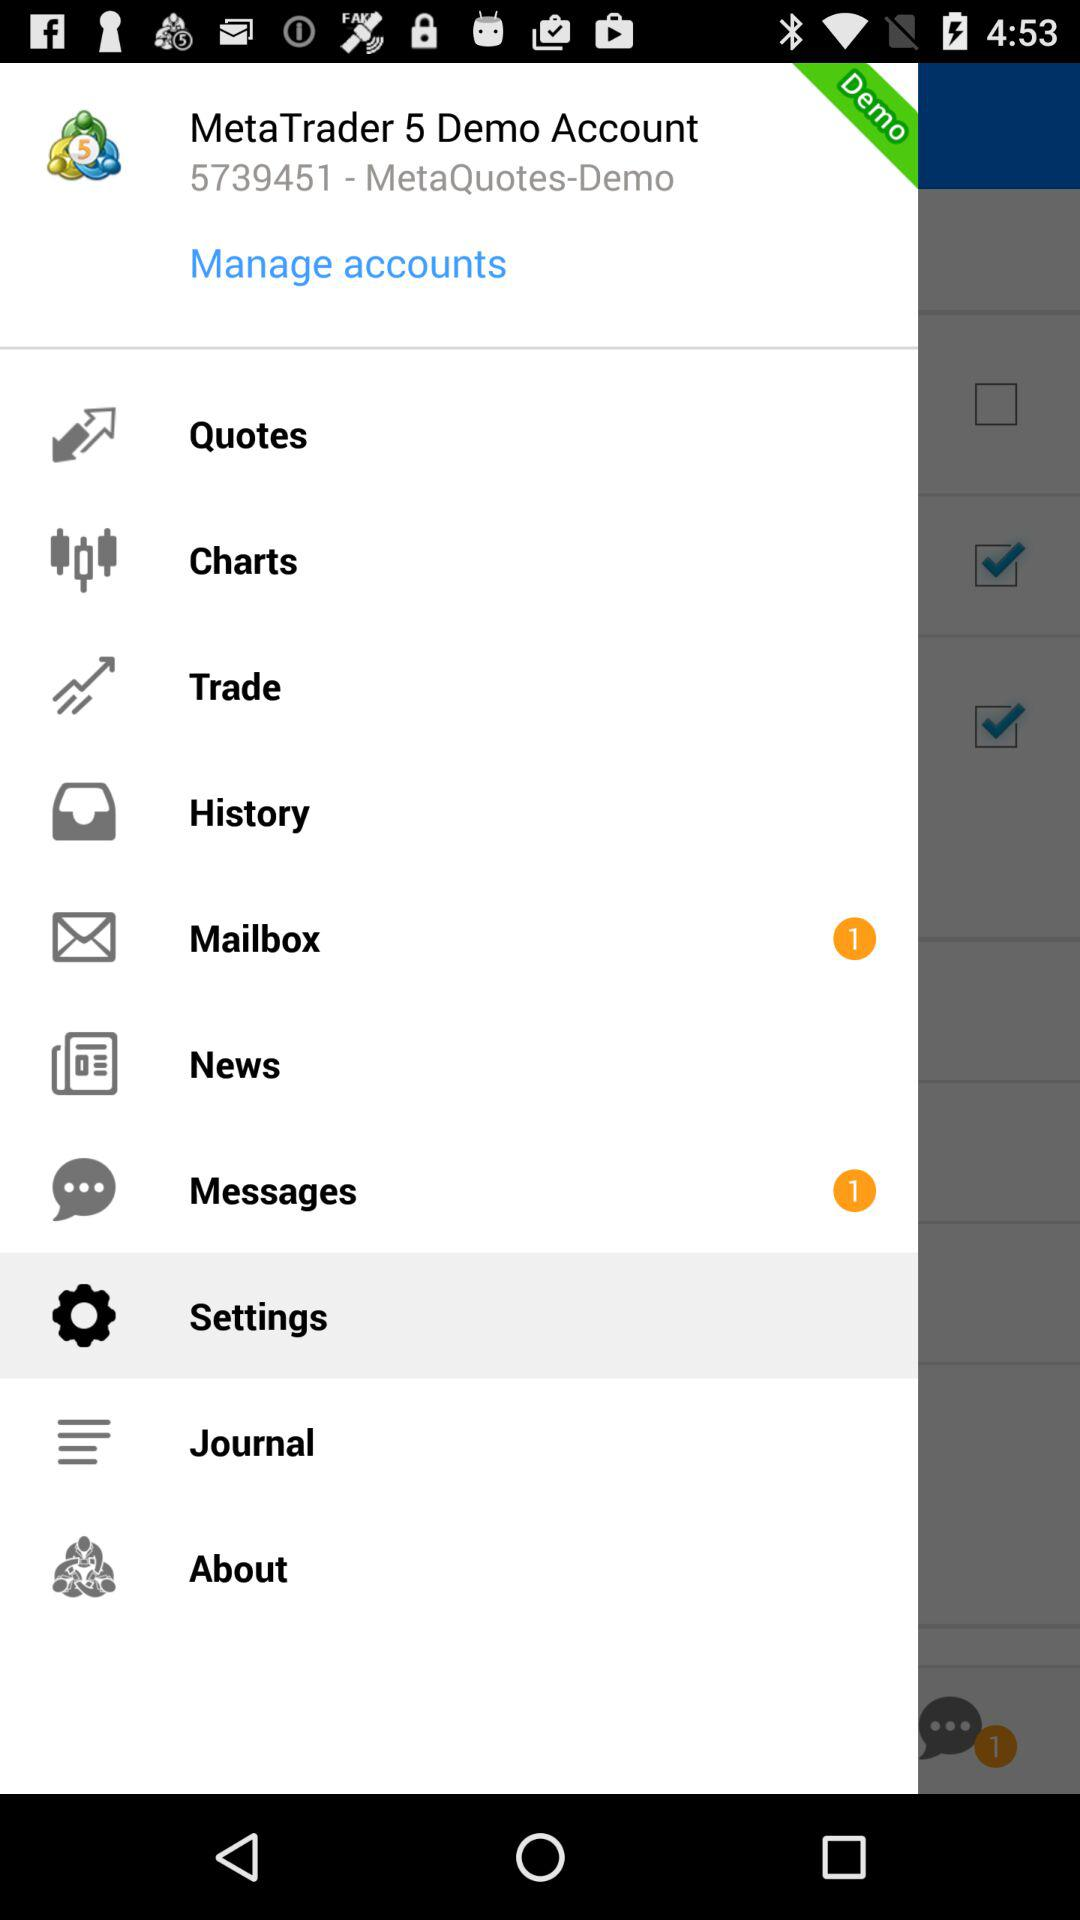What is the name of the application? The name of the application is "MetaTrader 5". 